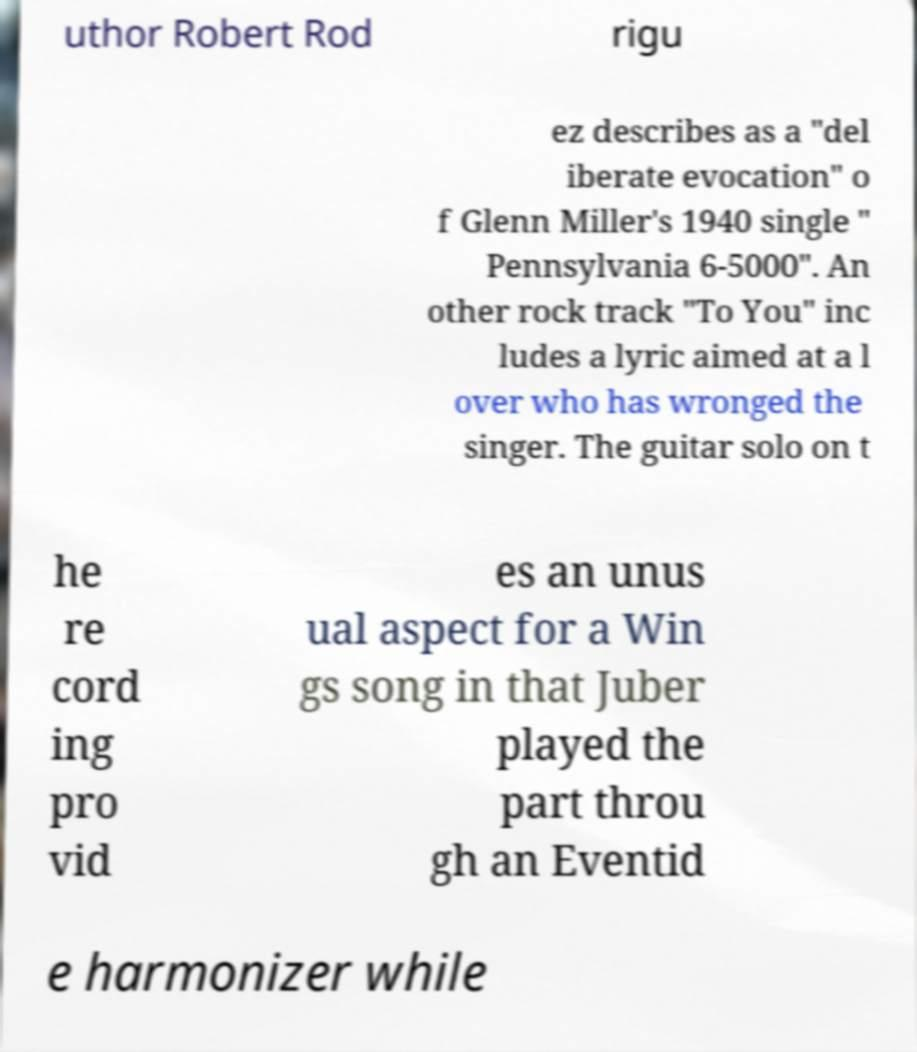For documentation purposes, I need the text within this image transcribed. Could you provide that? uthor Robert Rod rigu ez describes as a "del iberate evocation" o f Glenn Miller's 1940 single " Pennsylvania 6-5000". An other rock track "To You" inc ludes a lyric aimed at a l over who has wronged the singer. The guitar solo on t he re cord ing pro vid es an unus ual aspect for a Win gs song in that Juber played the part throu gh an Eventid e harmonizer while 